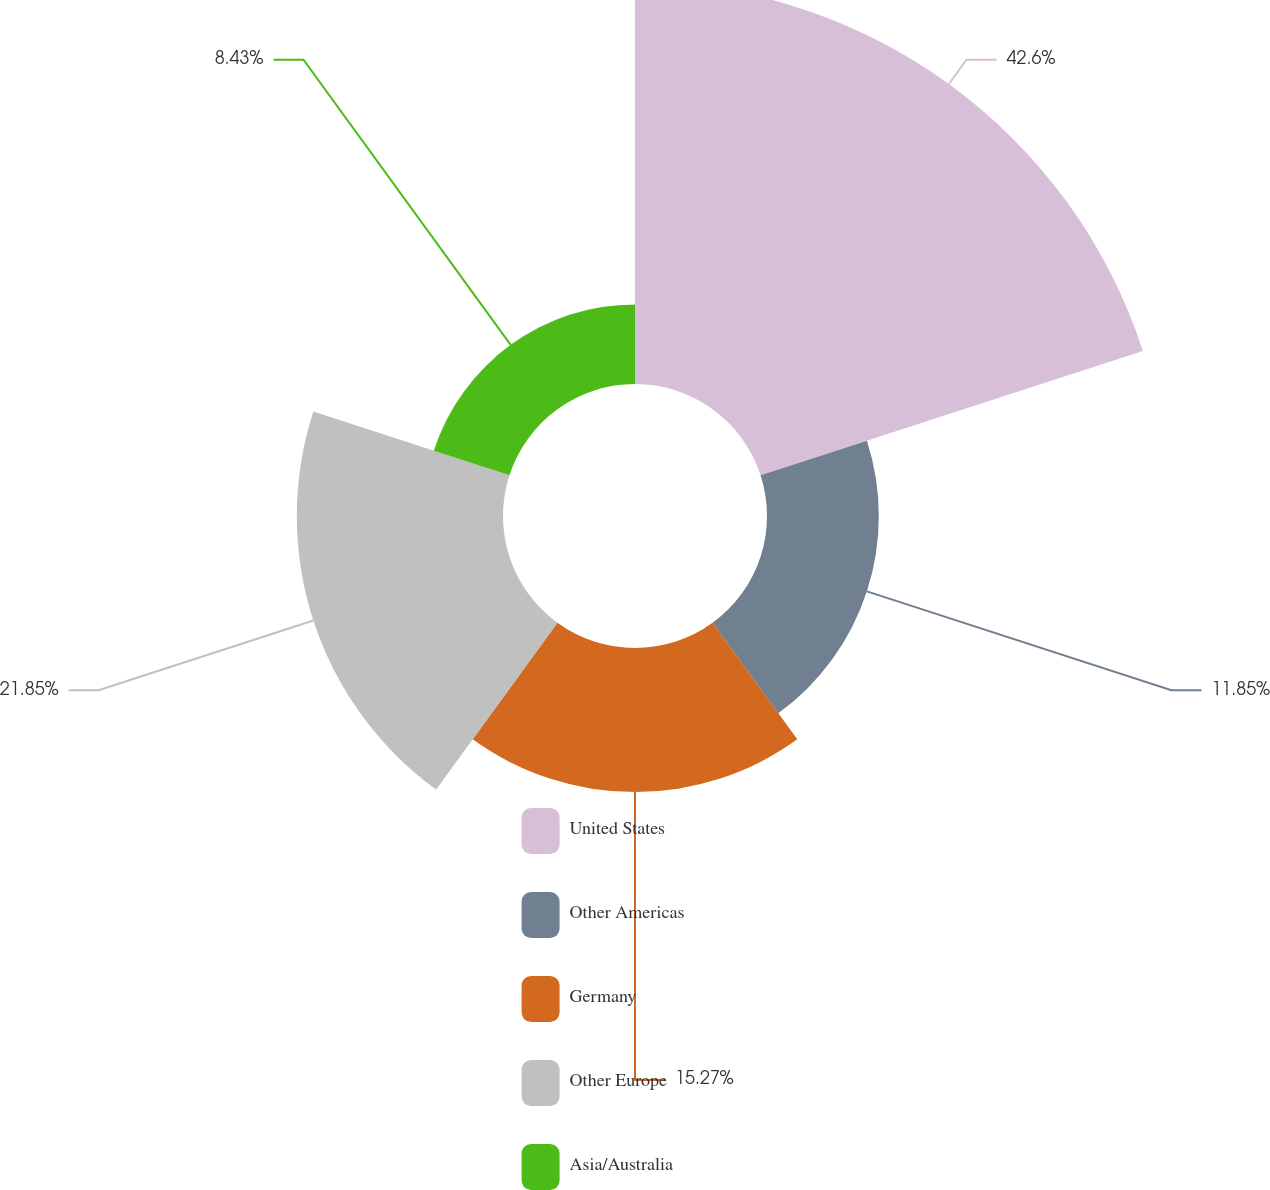Convert chart. <chart><loc_0><loc_0><loc_500><loc_500><pie_chart><fcel>United States<fcel>Other Americas<fcel>Germany<fcel>Other Europe<fcel>Asia/Australia<nl><fcel>42.6%<fcel>11.85%<fcel>15.27%<fcel>21.85%<fcel>8.43%<nl></chart> 